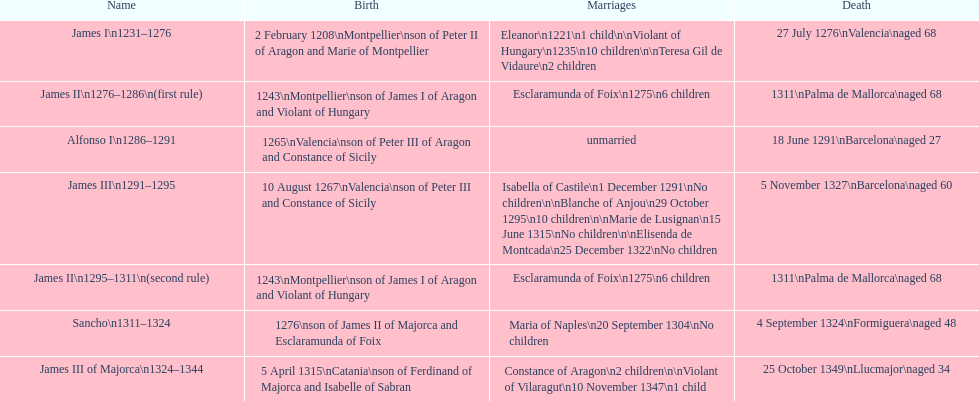How long was james ii in power, including his second rule? 26 years. 